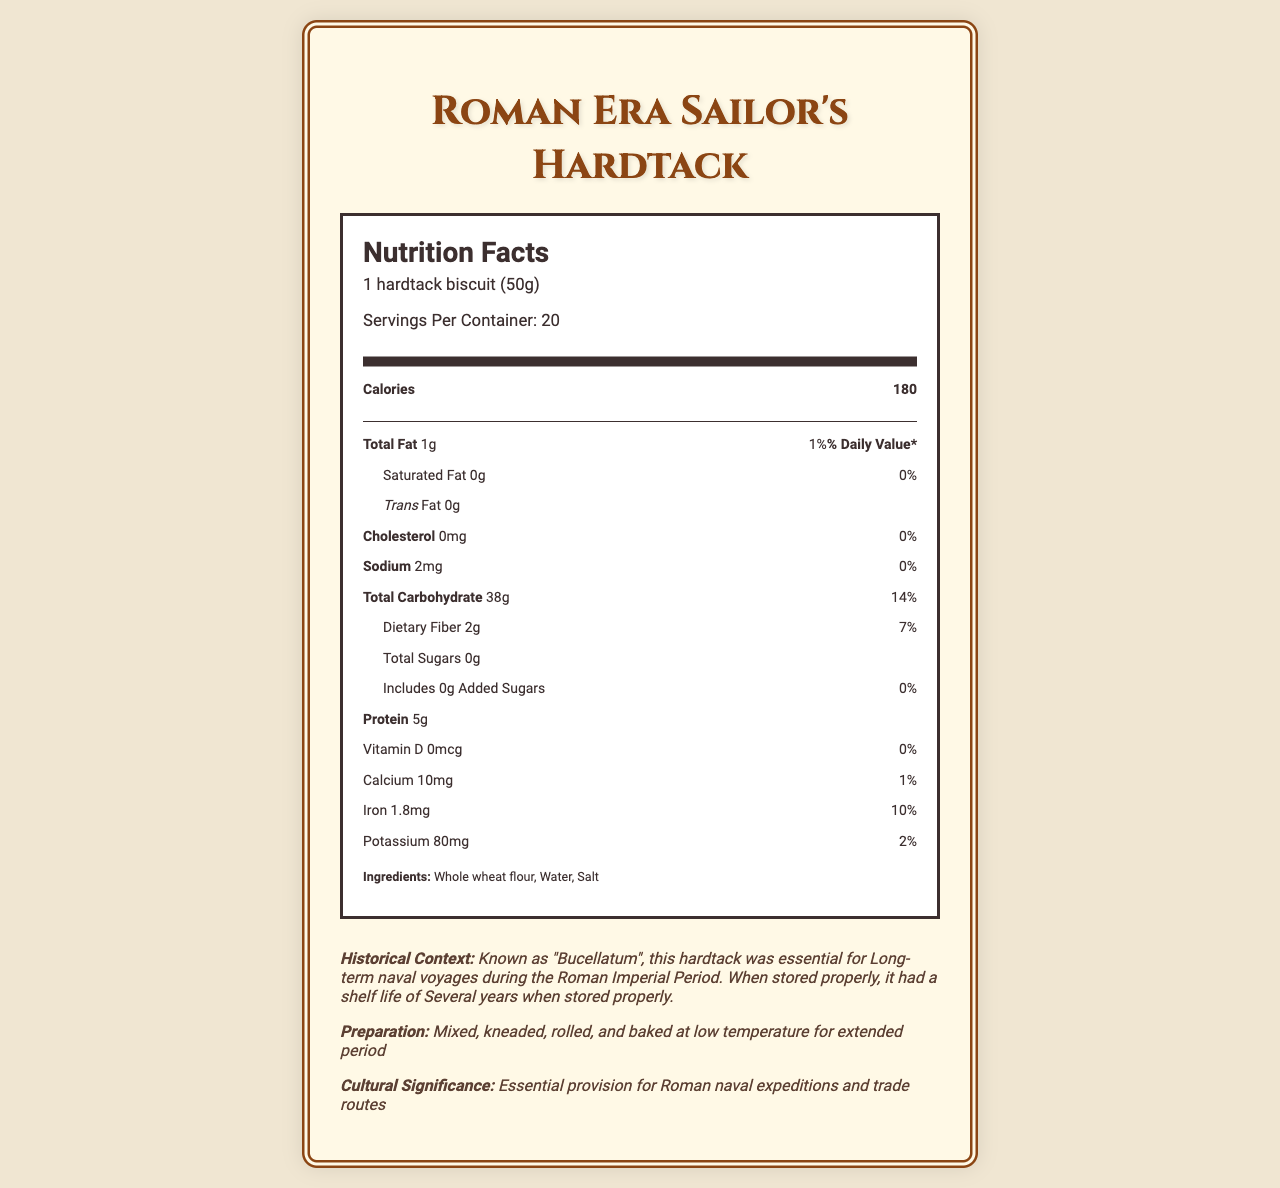What is the serving size of the Roman hardtack biscuit? The serving size is clearly stated at the beginning of the nutrition facts section of the document.
Answer: 1 hardtack biscuit (50g) How many calories are in one serving of the hardtack? The number of calories per serving is listed under the main information section of the nutrition label.
Answer: 180 What is the main ingredient in the hardtack? The main ingredient is listed first in the ingredients section, which typically indicates it is the primary component.
Answer: Whole wheat flour What is the percentage of the daily value of iron provided by one serving of the hardtack? The document states that one serving provides 1.8mg of iron, which corresponds to 10% of the daily value.
Answer: 10% How much dietary fiber is in one biscuit? The amount of dietary fiber is stated under the carbohydrate section of the nutrition facts.
Answer: 2g What is the common name of the hardtack used during the Roman era? The historical context section identifies the common name as Bucellatum.
Answer: Bucellatum How does the modern version differ from the ancient version of hardtack? A. Longer shelf life, coarser texture, different grains B. Similar shelf life, finer texture, might contain preservatives C. Lower carbohydrate content, higher moisture content, contains preservatives The document mentions that modern versions may include preservatives and might have a finer texture compared to the ancient version.
Answer: B Which of the following is a complementary food recommended to eat with hardtack? A. Butter B. Olive oil C. Cheese D. Fruits Olive oil is listed as a complementary food in the document.
Answer: B Is the hardtack high in total fat? According to the nutrition facts, the hardtack contains only 1g of total fat, which is 1% of the daily value, indicating it is low in total fat.
Answer: No Summarize the nutritional and historical significance of the Roman hardtack documented in the provided information. The document outlines Bucellatum's role in sustaining Roman sailors with a high-carbohydrate, low-fat diet, emphasizing its long-term storage benefits and cultural significance on naval expeditions.
Answer: The Roman hardtack, known as Bucellatum, was a crucial provision for naval voyages during the Roman Imperial Period. Each biscuit provides 180 calories, mainly from carbohydrates, with minimal fat and protein. It was made from whole wheat flour, water, and salt, had a long shelf life, and was typically complemented with olive oil, vinegar, dried fish, and legumes. What are the main nutritional challenges associated with Roman hardtack? The document lists these specific nutritional deficiencies and challenges under the section discussing nutritional challenges.
Answer: Low in essential vitamins, minimal fat content, risk of dental issues due to hardness How many servings are in one container of the hardtack? The document states there are 20 servings per container.
Answer: 20 What is the cholesterol content per serving? The cholesterol content is clearly listed as 0mg in the nutrition facts.
Answer: 0mg Can this document confirm the exact baking temperature and duration used for the hardtack? The document states that the hardtack was baked at a low temperature for an extended period but does not specify exact details.
Answer: Not enough information What era was the hardtack primarily used? The historical context section indicates that the hardtack was primarily used during the Roman Imperial Period.
Answer: Roman Imperial Period What is the daily value percentage of potassium in a serving? The document states that there are 80mg of potassium per serving, which amounts to 2% of the daily value.
Answer: 2% 